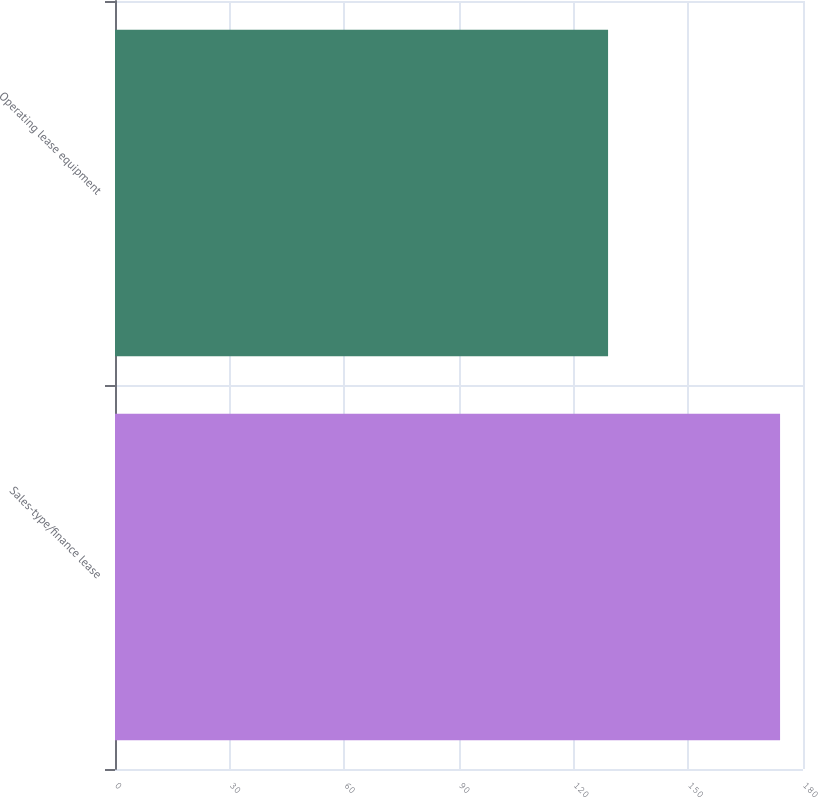Convert chart to OTSL. <chart><loc_0><loc_0><loc_500><loc_500><bar_chart><fcel>Sales-type/finance lease<fcel>Operating lease equipment<nl><fcel>174<fcel>129<nl></chart> 